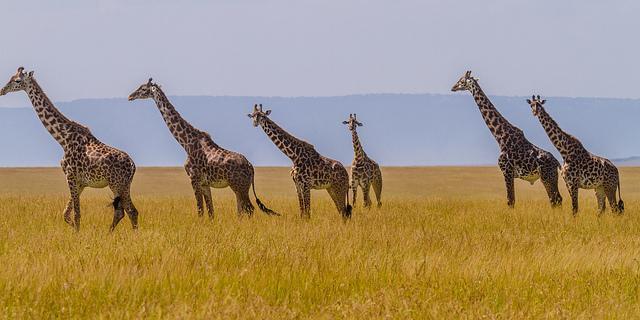How many giraffes can be seen?
Give a very brief answer. 5. 